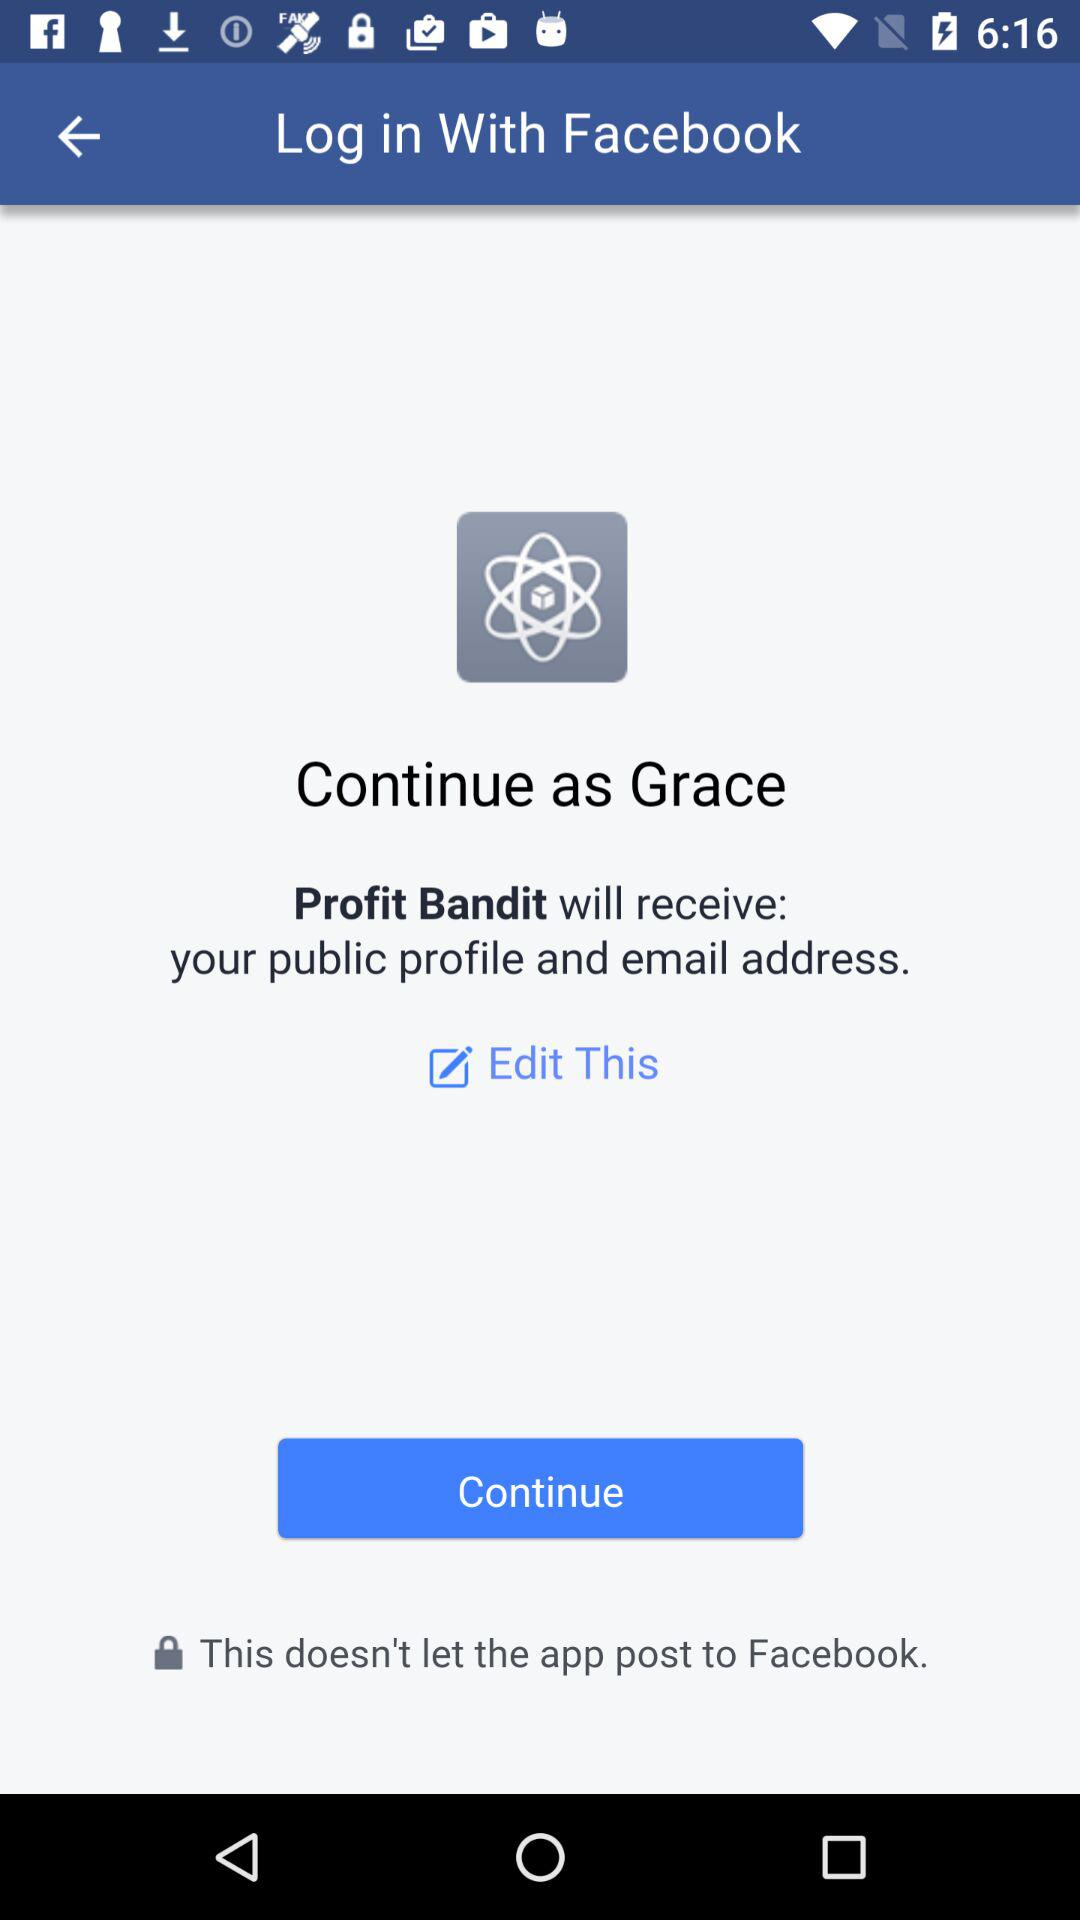What is the user name? The user name is Grace. 